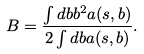<formula> <loc_0><loc_0><loc_500><loc_500>B = \frac { \int d { b } b ^ { 2 } a ( s , b ) } { 2 \int d { b } a ( s , b ) } .</formula> 